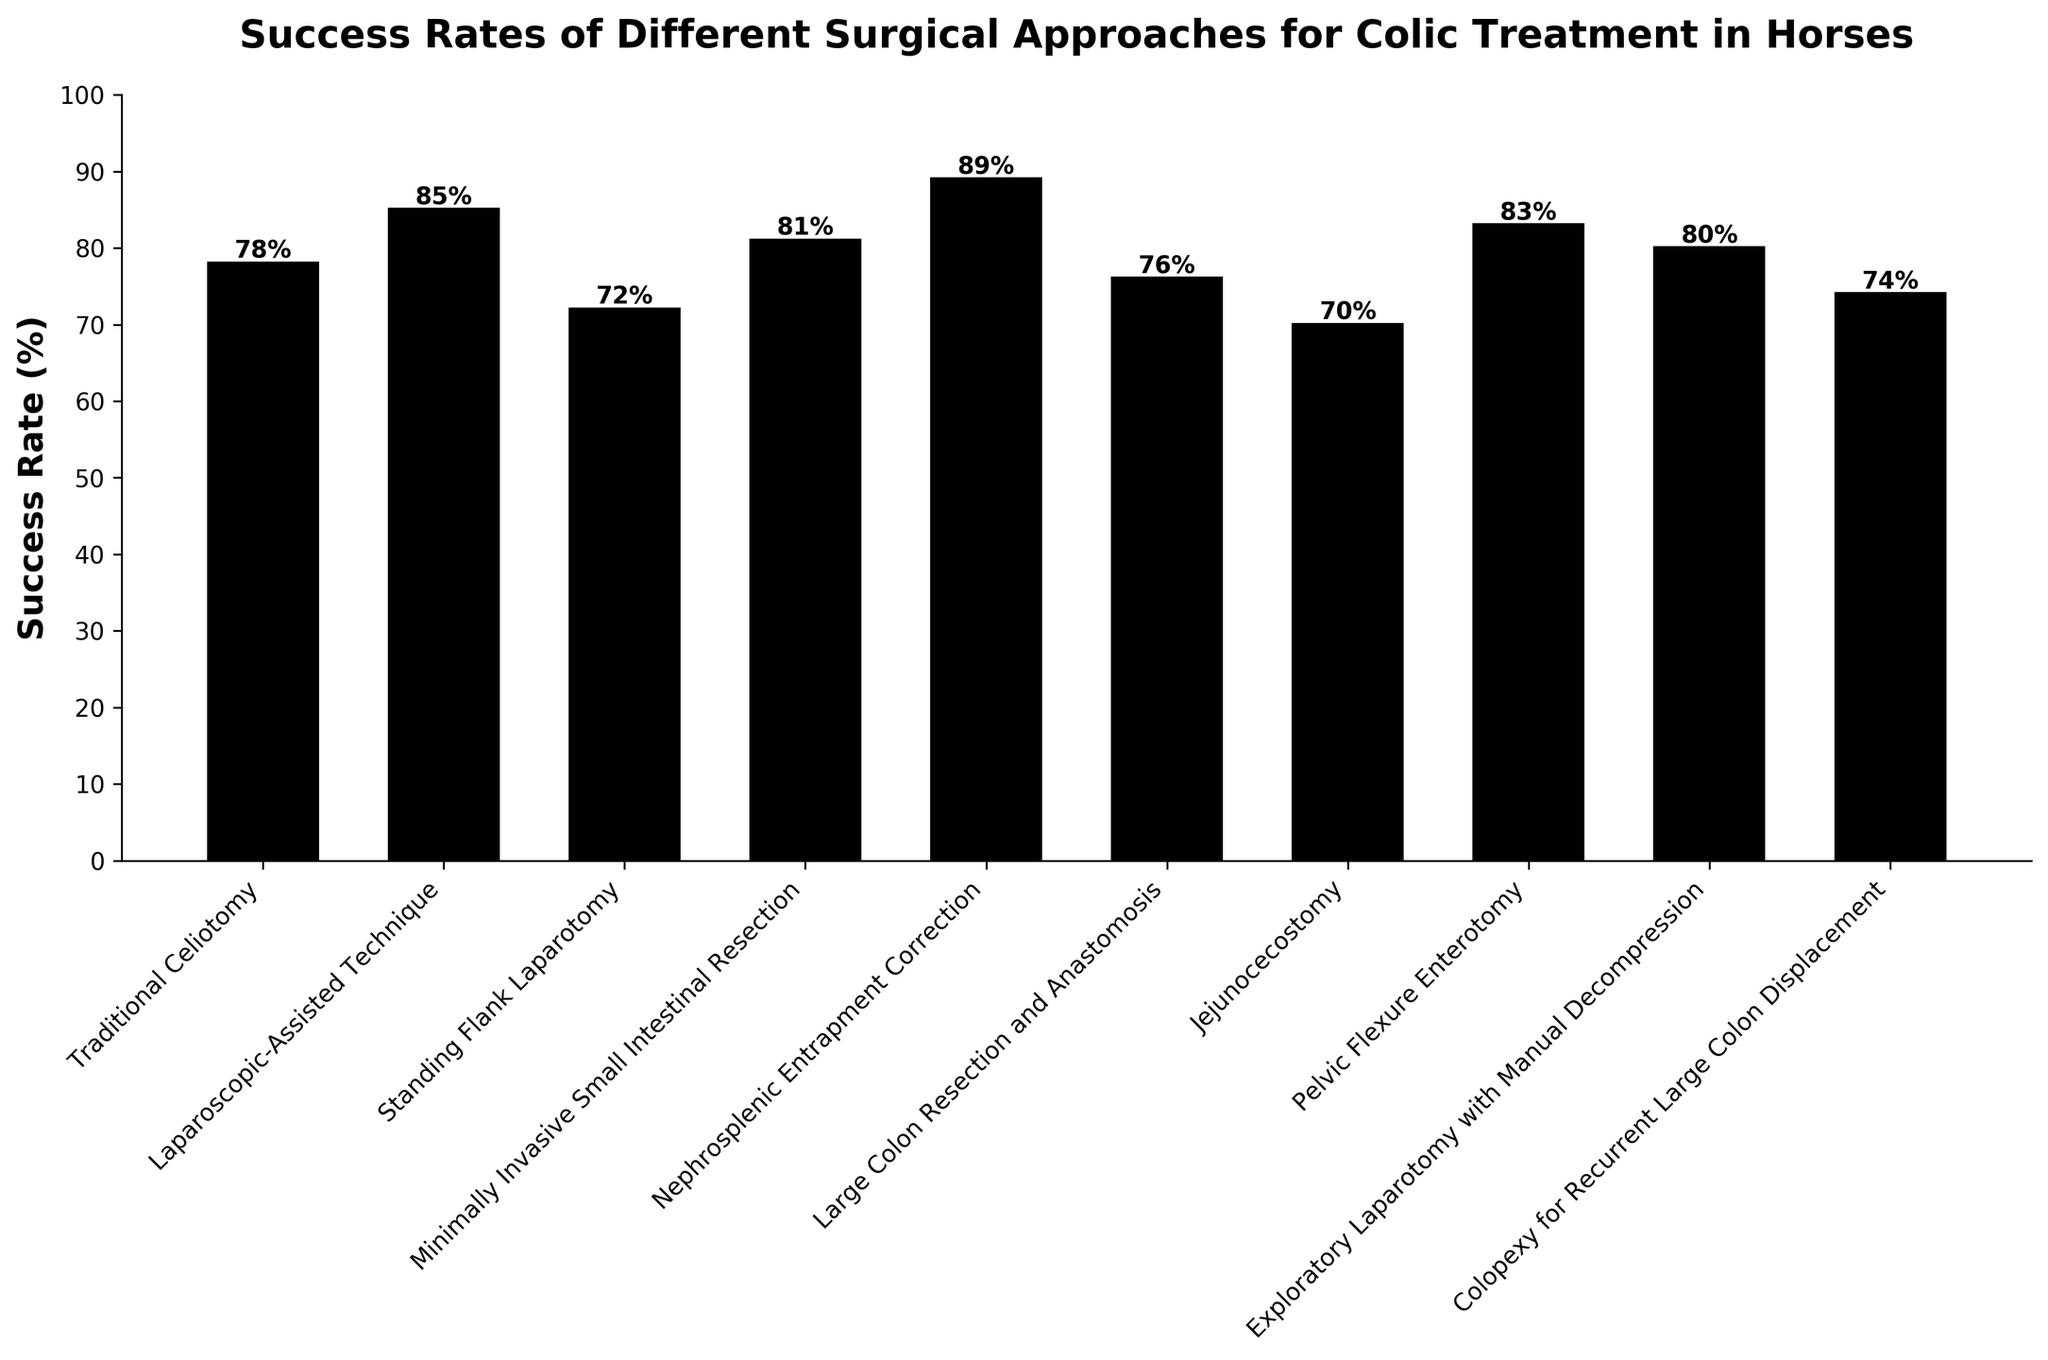What's the highest success rate among the approaches? To find the highest success rate, identify the tallest bar in the figure. The highest bar represents "Nephrosplenic Entrapment Correction" with a rate of 89%.
Answer: 89% Which surgical approach has the lowest success rate? Locate the shortest bar in the figure, which corresponds to the approach with the lowest success rate. It's "Jejunocecostomy" with a success rate of 70%.
Answer: Jejunocecostomy How much higher is the success rate of "Laparoscopic-Assisted Technique" compared to "Standing Flank Laparotomy"? Refer to the heights of the bars for both approaches. "Laparoscopic-Assisted Technique" has a success rate of 85%, and "Standing Flank Laparotomy" has 72%. The difference is 85% - 72% = 13%.
Answer: 13% Which surgical approaches have success rates above 80%? Identify all bars with heights above 80%. They are "Laparoscopic-Assisted Technique" (85%), "Minimally Invasive Small Intestinal Resection" (81%), "Pelvic Flexure Enterotomy" (83%), "Exploratory Laparotomy with Manual Decompression" (80%), and "Nephrosplenic Entrapment Correction" (89%).
Answer: Laparoscopic-Assisted Technique, Minimally Invasive Small Intestinal Resection, Pelvic Flexure Enterotomy, Exploratory Laparotomy with Manual Decompression, Nephrosplenic Entrapment Correction What is the average success rate of all the surgical approaches? Sum all the success rates and divide by the number of approaches. The rates are 78, 85, 72, 81, 89, 76, 70, 83, 80, and 74. Sum = 78 + 85 + 72 + 81 + 89 + 76 + 70 + 83 + 80 + 74 = 788. The number of approaches is 10. Hence, the average success rate is 788 / 10 = 78.8%.
Answer: 78.8% What is the range of success rates observed in the figure? The range is the difference between the highest and lowest success rates. The highest rate is 89% ("Nephrosplenic Entrapment Correction") and the lowest is 70% ("Jejunocecostomy"). The range is 89% - 70% = 19%.
Answer: 19% How many surgical approaches have a success rate higher than the average rate? First, calculate the average rate, which is 78.8%. Then count the approaches with rates above 78.8%. They are "Laparoscopic-Assisted Technique", "Minimally Invasive Small Intestinal Resection", "Pelvic Flexure Enterotomy", "Exploratory Laparotomy with Manual Decompression", and "Nephrosplenic Entrapment Correction". There are 5 such approaches.
Answer: 5 Is the success rate of "Large Colon Resection and Anastomosis" more than 75%? Check the height of the bar for "Large Colon Resection and Anastomosis". Its success rate is 76%, which is indeed more than 75%.
Answer: Yes Which two surgical approaches have success rates closest to each other? Compare the difference in heights of the bars representing each pair of approaches. The smallest difference is between "Exploratory Laparotomy with Manual Decompression" (80%) and "Minimally Invasive Small Intestinal Resection" (81%), a difference of 1%.
Answer: Exploratory Laparotomy with Manual Decompression and Minimally Invasive Small Intestinal Resection What percentage of the surgical approaches have success rates below 80%? Count the number of approaches with success rates below 80%. They are "Traditional Celiotomy" (78%), "Standing Flank Laparotomy" (72%), "Large Colon Resection and Anastomosis" (76%), "Jejunocecostomy" (70%), and "Colopexy for Recurrent Large Colon Displacement" (74%). There are 5 such approaches out of 10 total, so the percentage is (5/10) * 100 = 50%.
Answer: 50% 